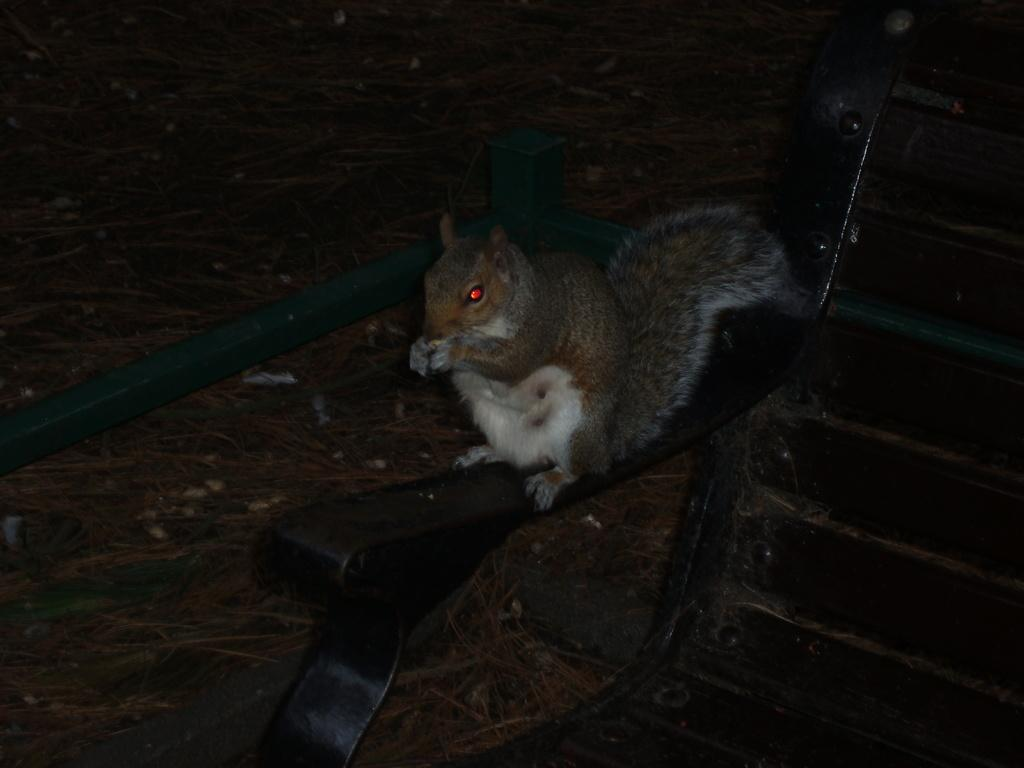What type of animal is in the image? There is a squirrel in the image. Where is the squirrel located? The squirrel is on a chair. What can be seen in the background of the image? There is dried grass visible in the background of the image. What type of brick structure can be seen in the image? There is no brick structure present in the image; it features a squirrel on a chair with dried grass in the background. 